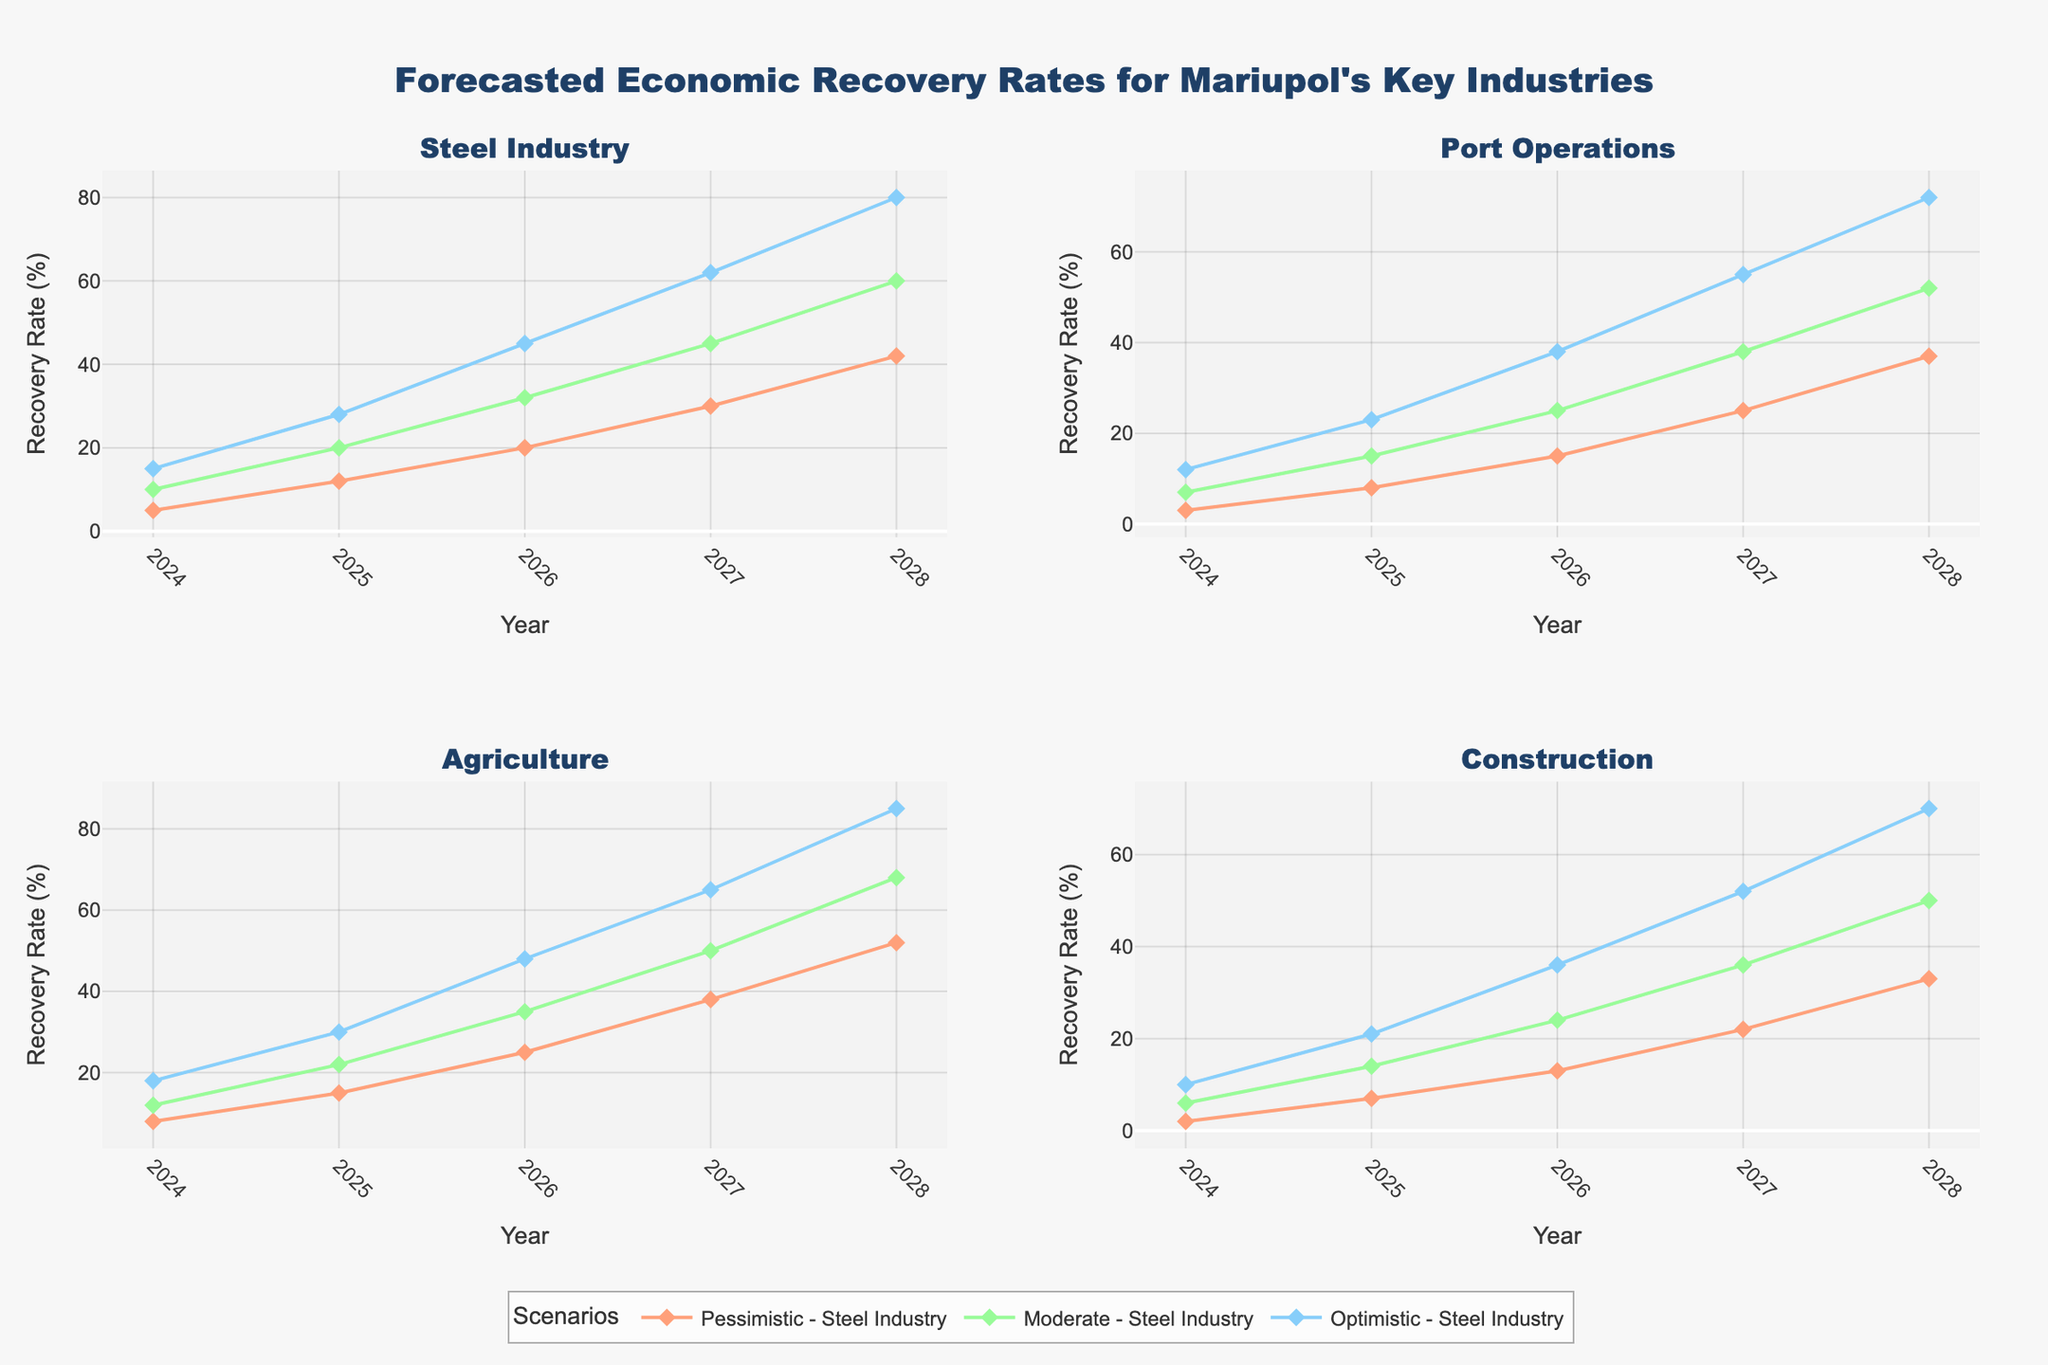What is the title of the chart? The title can be found at the top center of the chart, detailing the main subject of the visualization. The title is "Forecasted Economic Recovery Rates for Mariupol's Key Industries".
Answer: Forecasted Economic Recovery Rates for Mariupol's Key Industries Which industry is expected to recover the fastest under the optimistic scenario in 2024? To find this, look at the highest data point for each industry in the year 2024 under the optimistic scenario. The Agriculture industry has the highest recovery rate of 18%.
Answer: Agriculture By how much is the Steel Industry expected to recover in the pessimistic scenario from 2024 to 2025? Subtract the 2024 recovery rate for the Steel Industry under the pessimistic scenario (5%) from the 2025 recovery rate under the same scenario (12%). The difference is 12% - 5% = 7%.
Answer: 7% In which year is the recovery rate for Port Operations in the moderate scenario expected to reach 38%? Identify the year on the x-axis where the Port Operations plot line under the moderate scenario intersects the 38% mark on the y-axis. The year is 2027.
Answer: 2027 Under the optimistic scenario, which industry shows the largest increase in recovery rate from 2026 to 2027? Calculate the difference in recovery rates for each industry between 2026 and 2027 under the optimistic scenario, then find the largest increase. The increases are: Steel Industry (62%-45%=17%), Port Operations (55%-38%=17%), Agriculture (65%-48%=17%), Construction (52%-36%=16%). The largest increase is shared by the Steel Industry, Port Operations, and Agriculture (17%).
Answer: Steel Industry, Port Operations, Agriculture What is the average projected recovery rate for Construction in the pessimistic scenario from 2024 to 2028? Calculate the average of the recovery rates for the Construction industry in the pessimistic scenario over these years: (2+7+13+22+33)/5. The sum is 77, and the average is 77/5 = 15.4.
Answer: 15.4 Which scenario shows the steadiest growth for the Agriculture industry from 2024 to 2028? Observe the trend lines for the Agriculture industry across all scenarios. The steady growth without steep changes is best represented by the recovery rate under the moderate scenario.
Answer: Moderate In the optimistic scenario, which industry has the greatest rate of increase between 2024 and 2028? Calculate the rate of increase for each industry in the optimistic scenario from 2024 to 2028, and identify the largest increase. The rate of increases are: Steel Industry (80%-15%=65%), Port Operations (72%-12%=60%), Agriculture (85%-18%=67%), Construction (70%-10%=60%). Agriculture has the greatest increase of 67%.
Answer: Agriculture How does the projected recovery rate for Port Operations in 2026 compare between the optimistic and pessimistic scenarios? Compare the 2026 data points for Port Operations under the optimistic (38%) and pessimistic (15%) scenarios. The optimistic scenario is higher (38% > 15%).
Answer: The optimistic scenario recovery rate is higher 